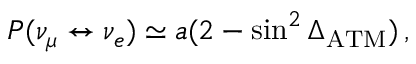<formula> <loc_0><loc_0><loc_500><loc_500>P ( \nu _ { \mu } \leftrightarrow \nu _ { e } ) \simeq a ( 2 - \sin ^ { 2 } \Delta _ { A T M } ) \, ,</formula> 